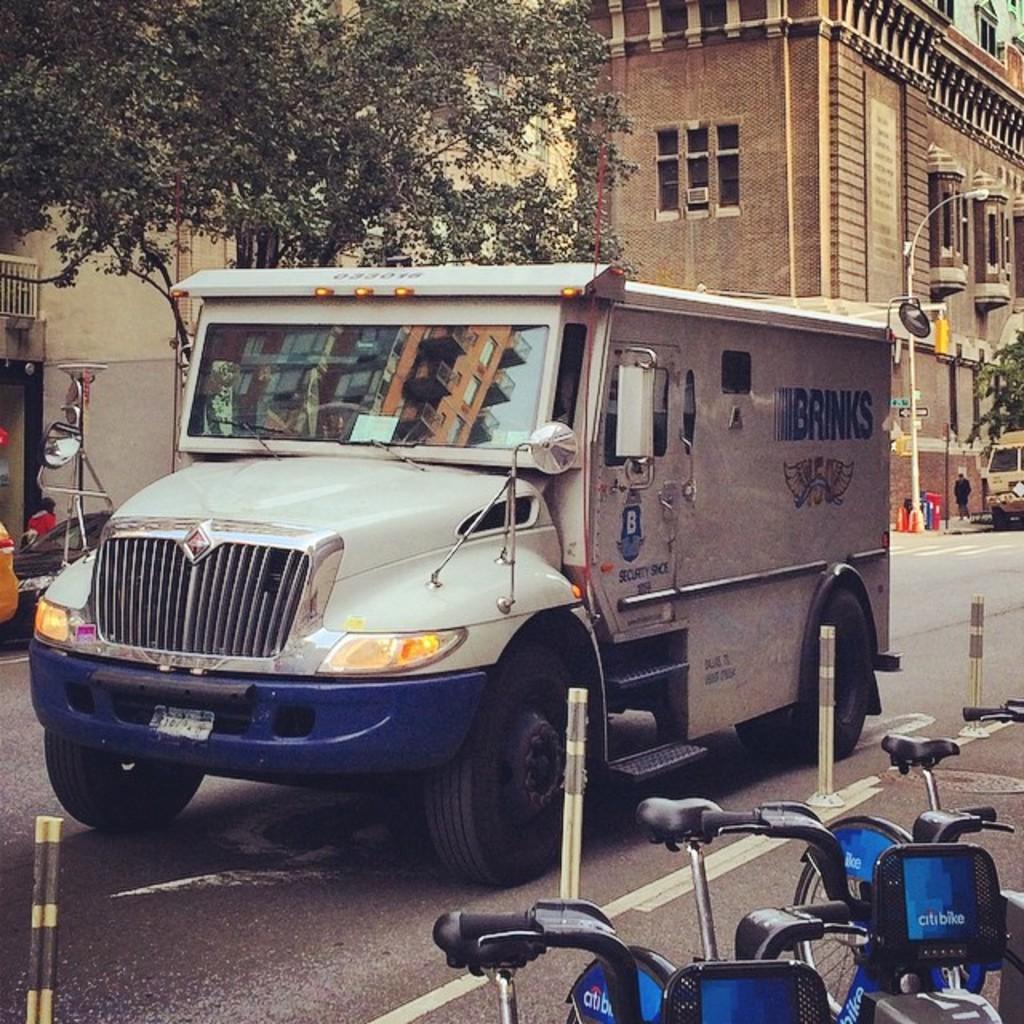Can you describe this image briefly? In this image we can see a vehicle which is moving on the road in the foreground of the image there are some bicycles which are parked on the road and there are some poles and in the background of the image there are some trees and buildings. 